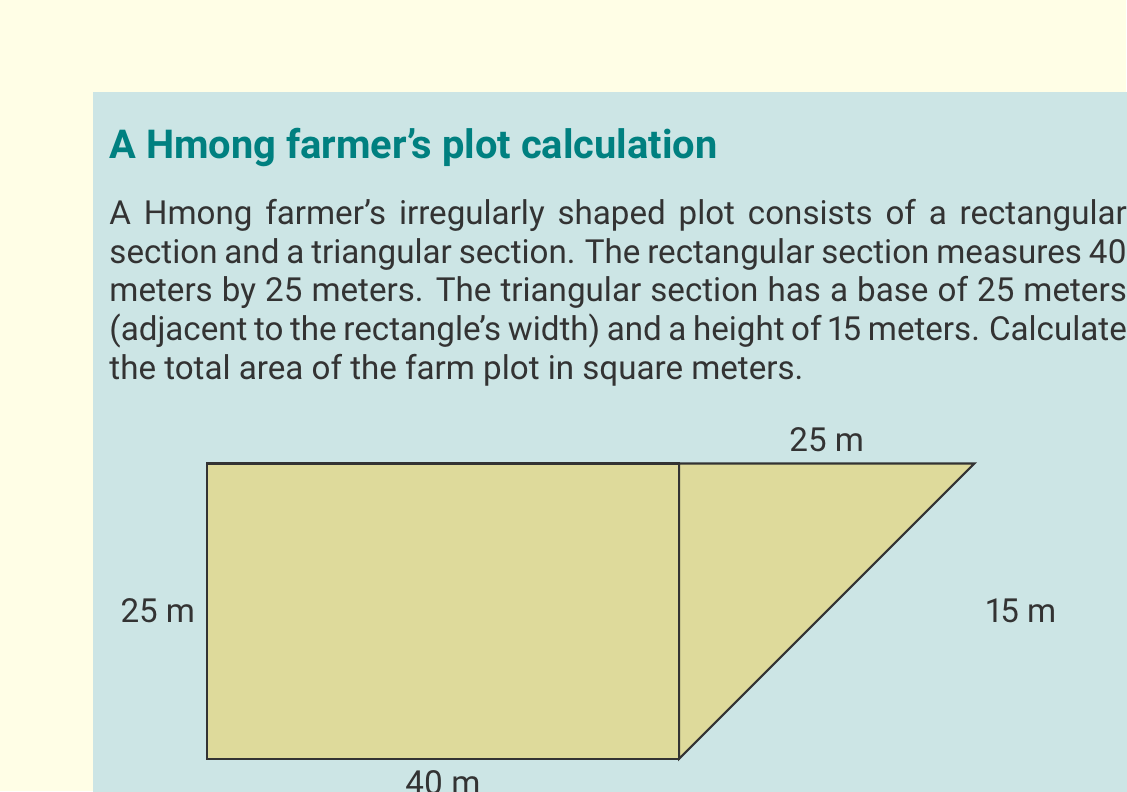Provide a solution to this math problem. To calculate the total area of the farm plot, we need to find the areas of both the rectangular and triangular sections, then add them together.

1. Area of the rectangular section:
   $$A_r = l \times w$$
   where $l$ is length and $w$ is width
   $$A_r = 40 \text{ m} \times 25 \text{ m} = 1000 \text{ m}^2$$

2. Area of the triangular section:
   $$A_t = \frac{1}{2} \times b \times h$$
   where $b$ is base and $h$ is height
   $$A_t = \frac{1}{2} \times 25 \text{ m} \times 15 \text{ m} = 187.5 \text{ m}^2$$

3. Total area of the farm plot:
   $$A_{total} = A_r + A_t$$
   $$A_{total} = 1000 \text{ m}^2 + 187.5 \text{ m}^2 = 1187.5 \text{ m}^2$$

Therefore, the total area of the Hmong farmer's irregularly shaped plot is 1187.5 square meters.
Answer: 1187.5 m² 